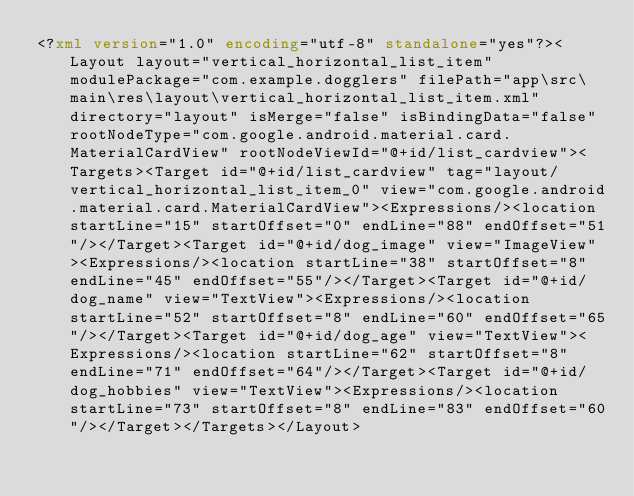<code> <loc_0><loc_0><loc_500><loc_500><_XML_><?xml version="1.0" encoding="utf-8" standalone="yes"?><Layout layout="vertical_horizontal_list_item" modulePackage="com.example.dogglers" filePath="app\src\main\res\layout\vertical_horizontal_list_item.xml" directory="layout" isMerge="false" isBindingData="false" rootNodeType="com.google.android.material.card.MaterialCardView" rootNodeViewId="@+id/list_cardview"><Targets><Target id="@+id/list_cardview" tag="layout/vertical_horizontal_list_item_0" view="com.google.android.material.card.MaterialCardView"><Expressions/><location startLine="15" startOffset="0" endLine="88" endOffset="51"/></Target><Target id="@+id/dog_image" view="ImageView"><Expressions/><location startLine="38" startOffset="8" endLine="45" endOffset="55"/></Target><Target id="@+id/dog_name" view="TextView"><Expressions/><location startLine="52" startOffset="8" endLine="60" endOffset="65"/></Target><Target id="@+id/dog_age" view="TextView"><Expressions/><location startLine="62" startOffset="8" endLine="71" endOffset="64"/></Target><Target id="@+id/dog_hobbies" view="TextView"><Expressions/><location startLine="73" startOffset="8" endLine="83" endOffset="60"/></Target></Targets></Layout></code> 